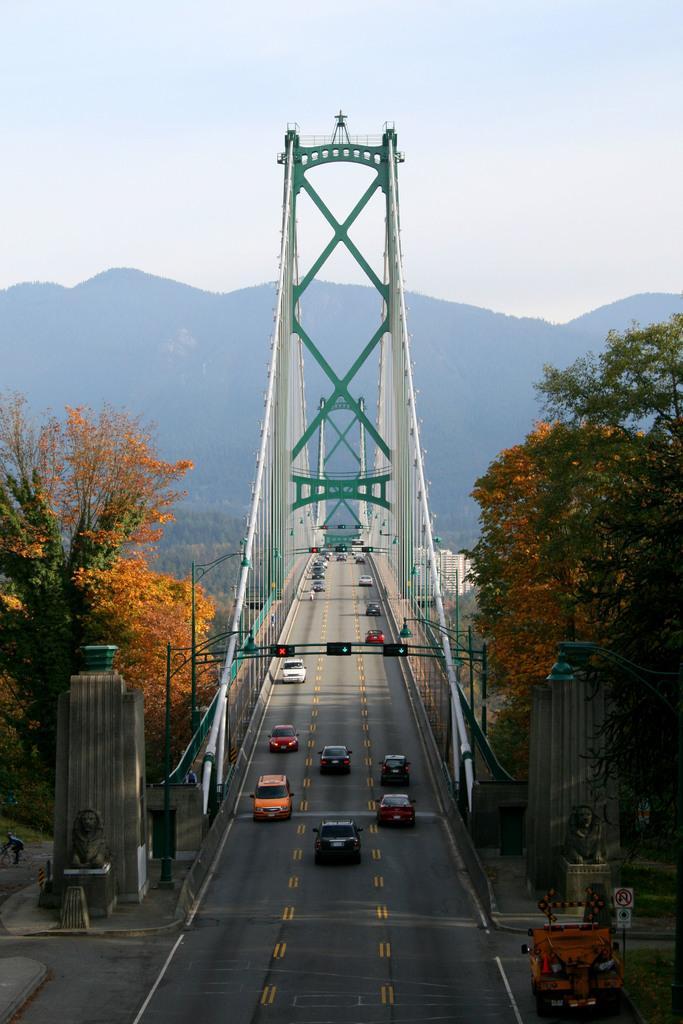How would you summarize this image in a sentence or two? In the foreground of the picture we can see trees, road and a bridge, on the bridge we can see vehicles moving. In the middle of the picture there are hills. At the top there is sky. 